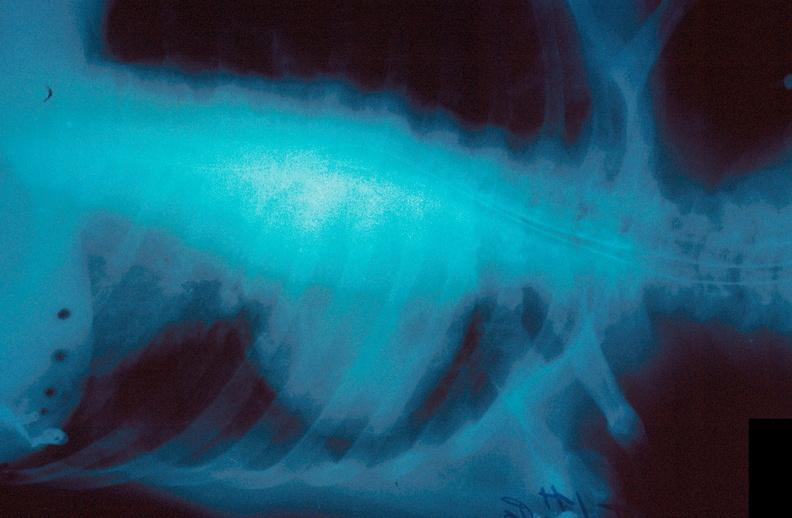what does this image show?
Answer the question using a single word or phrase. Lung 